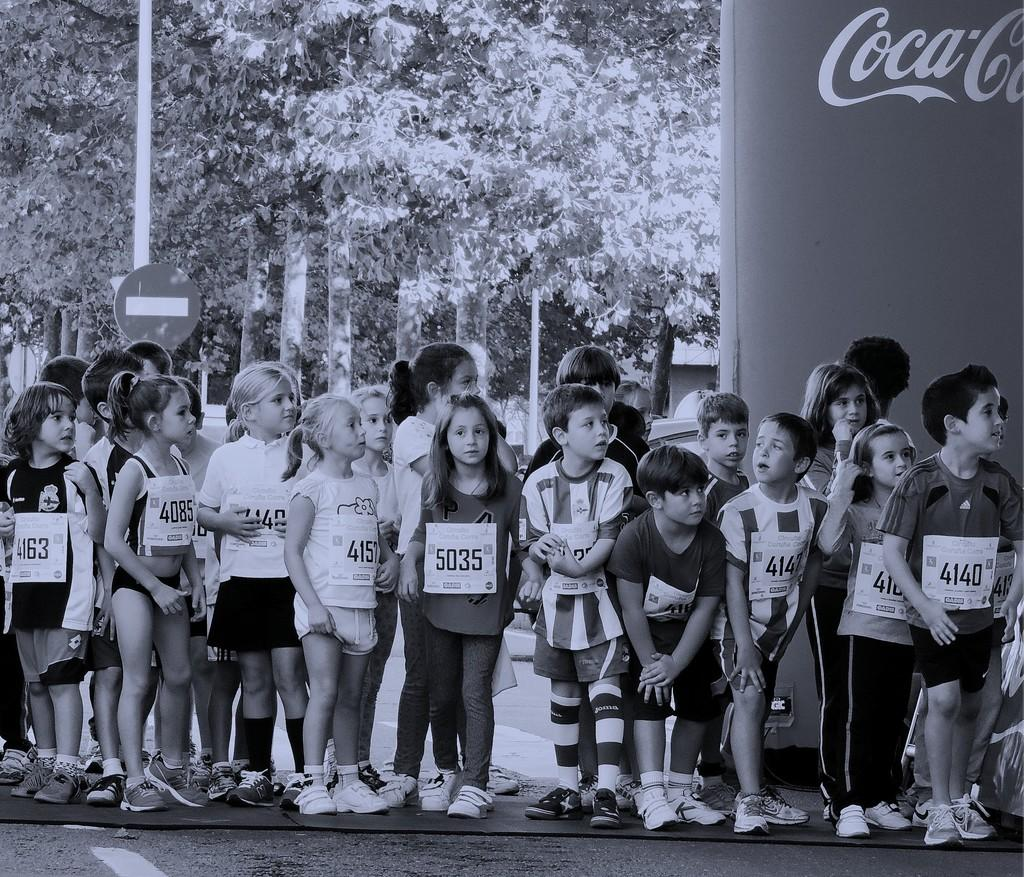What is the main subject of the image? The main subject of the image is children standing. What can be seen in the background of the image? There are trees visible in the background of the image. How many flowers are visible in the image? There are no flowers visible in the image. What is the price of the children standing in the image? The image does not provide any information about the price of the children standing. 